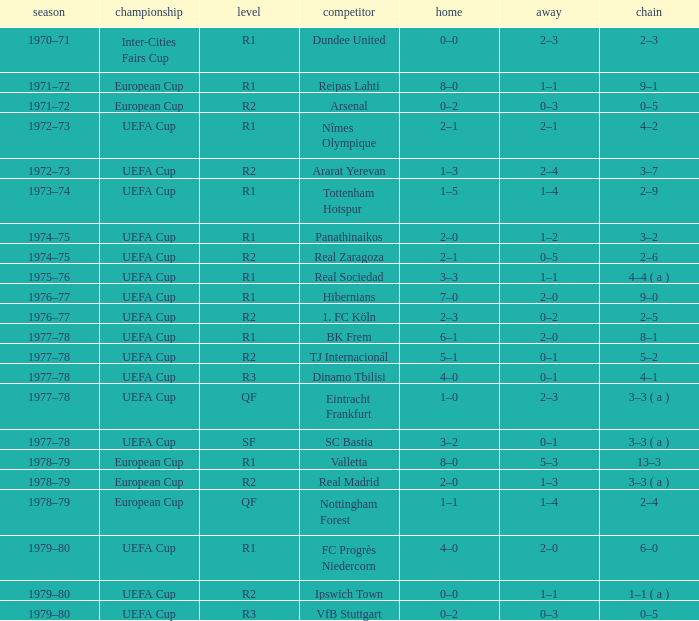Which Home has a Competition of european cup, and a Round of qf? 1–1. 